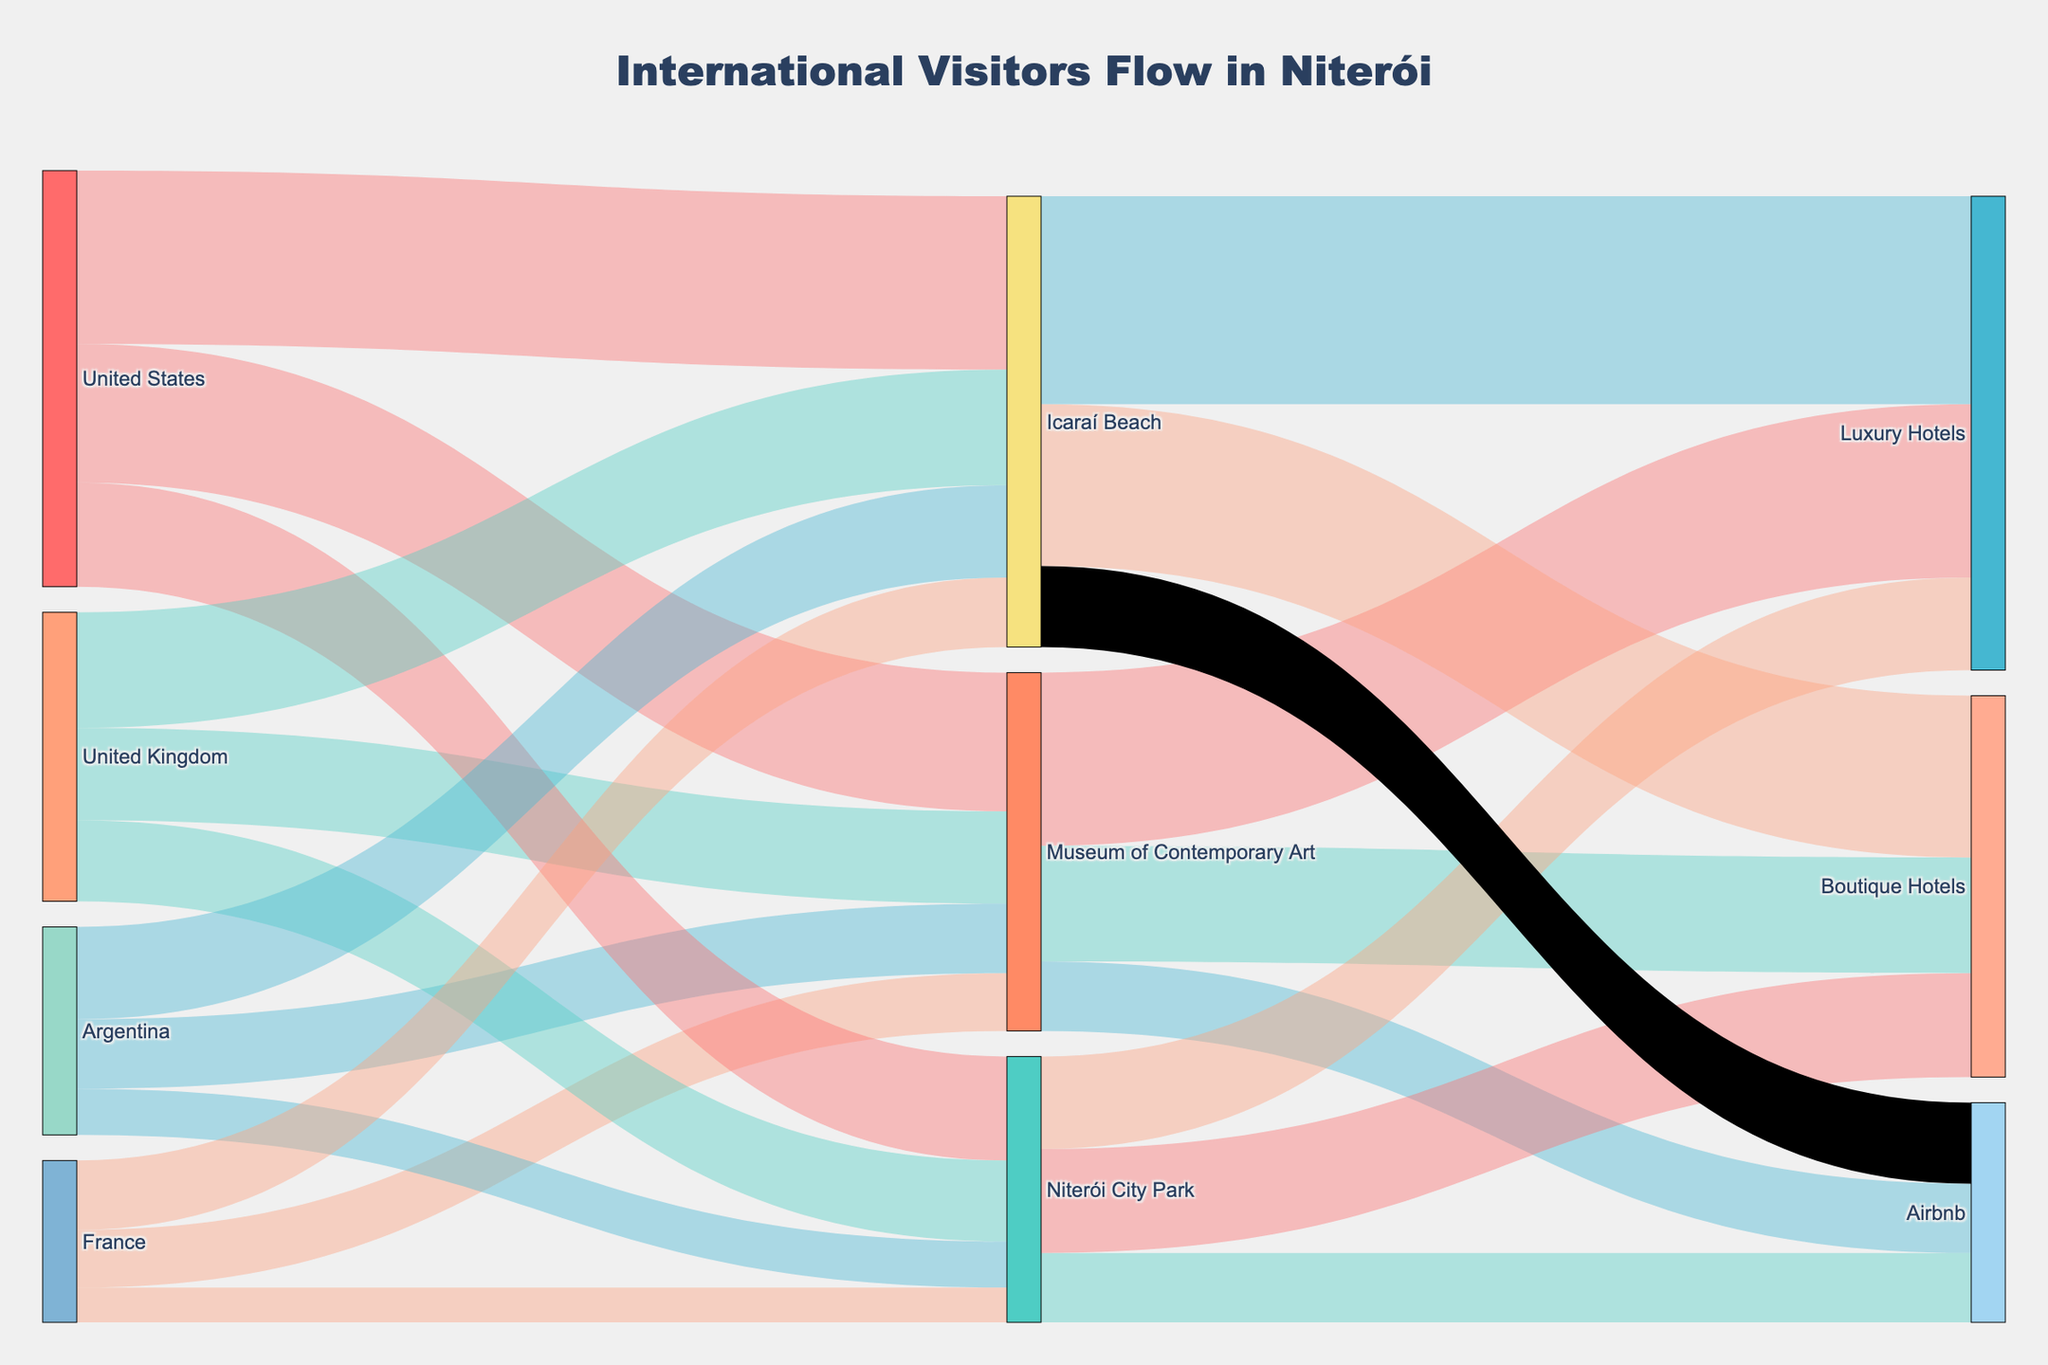How many international visitors are from the United States visiting Icaraí Beach? Look for the connection from the "United States" node to "Icaraí Beach" and read the value.
Answer: 1500 Which attraction is most preferred by visitors from the United Kingdom? Compare the values of links from the "United Kingdom" node to various attractions: Museum of Contemporary Art (800), Niterói City Park (700), and Icaraí Beach (1000). The highest value indicates the most preferred attraction.
Answer: Icaraí Beach What is the total number of visitors from France to Niterói's attractions depicted in the diagram? Add up the values of connections from "France" to different attractions: Museum of Contemporary Art (500), Niterói City Park (300), and Icaraí Beach (600). The total is 500 + 300 + 600.
Answer: 1400 Which accommodation type is most popular among visitors to the Museum of Contemporary Art? Compare the values of links from the "Museum of Contemporary Art" node to various accommodations: Luxury Hotels (1500), Boutique Hotels (1000), and Airbnb (600). The highest value indicates the most popular accommodation type.
Answer: Luxury Hotels Do more visitors stay at Boutique Hotels or Luxury Hotels after visiting Icaraí Beach? Compare the values of links from the "Icaraí Beach" node to Boutique Hotels (1400) and Luxury Hotels (1800). Determine which value is larger.
Answer: Luxury Hotels What is the average number of visitors from the United States across all shown attractions? Add the values of connections from "United States" to all attractions: Museum of Contemporary Art (1200), Niterói City Park (900), and Icaraí Beach (1500). Then divide by the number of attractions, which is 3. Calculation: (1200 + 900 + 1500) / 3.
Answer: 1200 Identify the least preferred attraction by visitors from Argentina. Compare the values of links from "Argentina" to various attractions: Museum of Contemporary Art (600), Niterói City Park (400), and Icaraí Beach (800). The lowest value indicates the least preferred attraction.
Answer: Niterói City Park What is the distributive proportion of visitors staying in Airbnb after visiting Niterói City Park compared to total city park visitors? Find the value of visitors staying in Airbnb after visiting Niterói City Park, which is 600. Then sum up the total visitors to Niterói City Park: 900 (Luxury Hotels) + 900 (Boutique Hotels) + 600 (Airbnb) = 2400. Proportion calculation: 600 / 2400.
Answer: 25% Which country has the smallest number of visitors choosing Airbnb for accommodation after visiting any attraction? Observe the connections from different countries to all attractions and Airbnb. Identify the smallest sum for any country.
Answer: France What is the total number of visitors staying at Boutique Hotels after visiting all attractions combined? Sum the values of connections from all attractions to Boutique Hotels: Museum of Contemporary Art (1000), Niterói City Park (900), and Icaraí Beach (1400). Calculation: 1000 + 900 + 1400.
Answer: 3300 